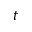Convert formula to latex. <formula><loc_0><loc_0><loc_500><loc_500>t</formula> 